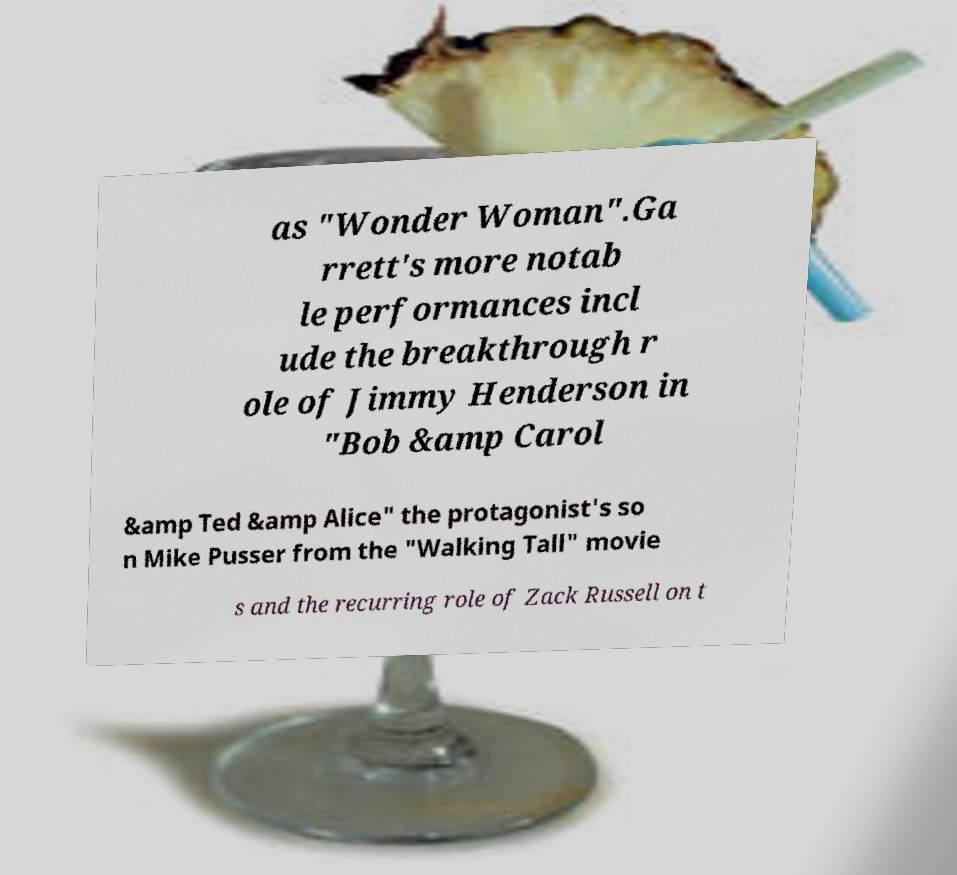Please identify and transcribe the text found in this image. as "Wonder Woman".Ga rrett's more notab le performances incl ude the breakthrough r ole of Jimmy Henderson in "Bob &amp Carol &amp Ted &amp Alice" the protagonist's so n Mike Pusser from the "Walking Tall" movie s and the recurring role of Zack Russell on t 